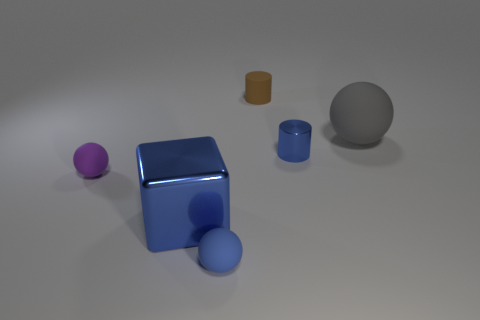What materials do the objects appear to be made of? The objects in the image seem to be made of different materials. The purple and blue balls, as well as the blue box and cylinder, appear to have a rubbery texture. The small brown cylinder looks like it could be made of wood or plastic, while the large grey sphere has a matte surface, possibly resembling concrete or stone. 